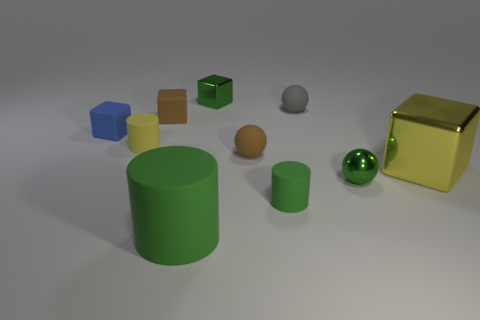Subtract all brown matte cubes. How many cubes are left? 3 Subtract 2 blocks. How many blocks are left? 2 Subtract all balls. How many objects are left? 7 Subtract all purple cubes. How many green cylinders are left? 2 Subtract 0 red balls. How many objects are left? 10 Subtract all blue cylinders. Subtract all gray balls. How many cylinders are left? 3 Subtract all gray matte balls. Subtract all small balls. How many objects are left? 6 Add 8 large yellow shiny cubes. How many large yellow shiny cubes are left? 9 Add 5 tiny gray matte things. How many tiny gray matte things exist? 6 Subtract all yellow cylinders. How many cylinders are left? 2 